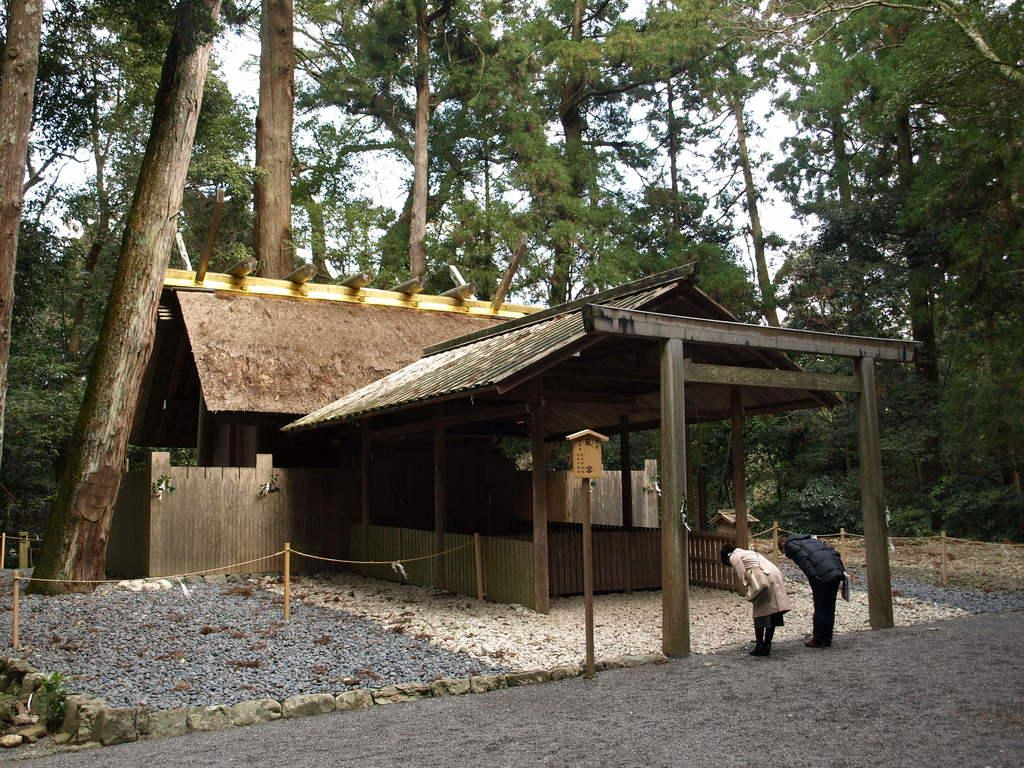How many people are in the image? There are two people in the image. What are the people wearing? The people are wearing clothes and shoes. What object can be seen in the image that is typically used for carrying personal belongings? There is a handbag in the image. What type of natural feature is present in the image? There are stones and trees in the image. What architectural feature can be seen in the image? There is a pole in the image. What is visible in the background of the image? The sky is visible in the image. What type of structure is present in the image? There is a house in the image. What is the cause of the office trip in the image? There is no office or trip mentioned in the image; it features two people, a handbag, stones, trees, a pole, the sky, and a house. 